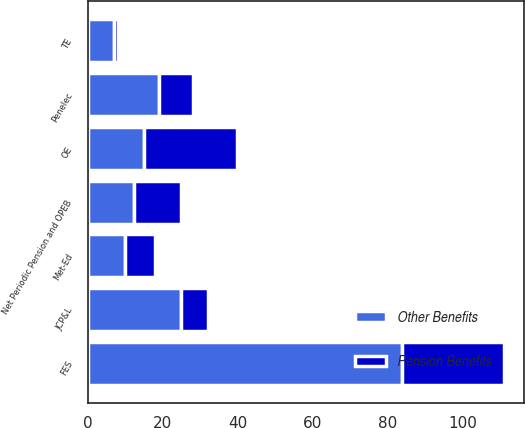<chart> <loc_0><loc_0><loc_500><loc_500><stacked_bar_chart><ecel><fcel>Net Periodic Pension and OPEB<fcel>FES<fcel>OE<fcel>TE<fcel>JCP&L<fcel>Met-Ed<fcel>Penelec<nl><fcel>Other Benefits<fcel>12.5<fcel>84<fcel>15<fcel>7<fcel>25<fcel>10<fcel>19<nl><fcel>Pension Benefits<fcel>12.5<fcel>27<fcel>25<fcel>1<fcel>7<fcel>8<fcel>9<nl></chart> 